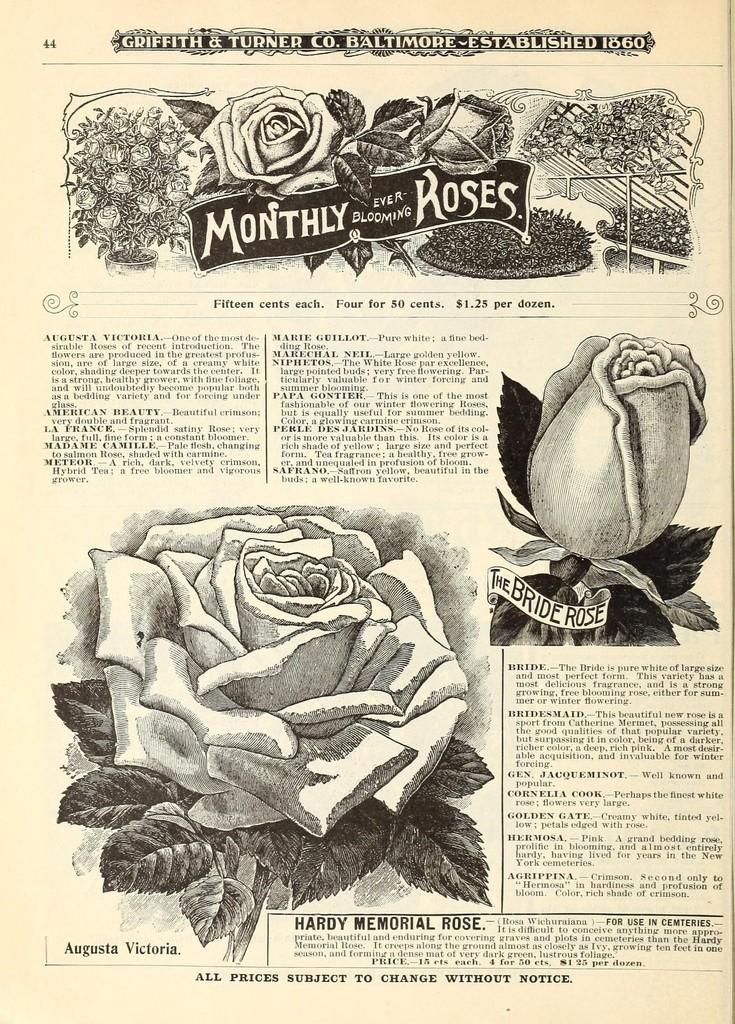What type of flowers are shown on the page? There are rose flowers depicted on the page. What else can be seen on the page besides the flowers? There are pictures of plants on the page. Is there any written content on the page? Yes, there is text written on the page. What type of discovery was made by the flower in the image? There is no indication in the image that the flower made any discovery, as flowers do not have the ability to make discoveries. 